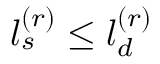<formula> <loc_0><loc_0><loc_500><loc_500>l _ { s } ^ { ( r ) } \leq l _ { d } ^ { ( r ) }</formula> 